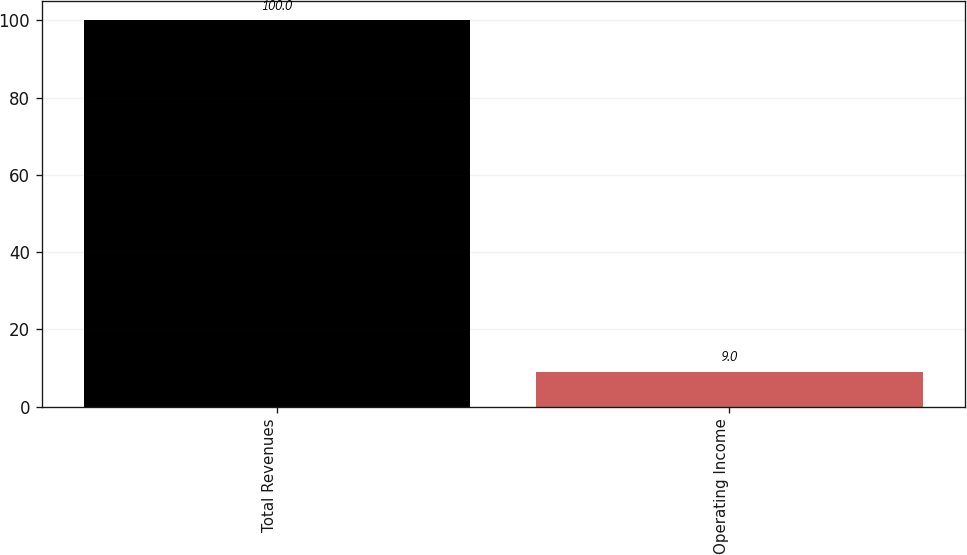Convert chart to OTSL. <chart><loc_0><loc_0><loc_500><loc_500><bar_chart><fcel>Total Revenues<fcel>Operating Income<nl><fcel>100<fcel>9<nl></chart> 